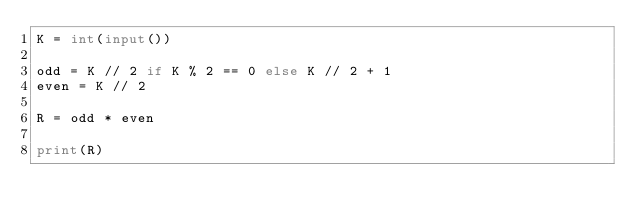<code> <loc_0><loc_0><loc_500><loc_500><_Python_>K = int(input())

odd = K // 2 if K % 2 == 0 else K // 2 + 1
even = K // 2

R = odd * even

print(R)
</code> 